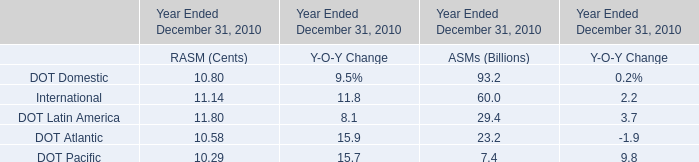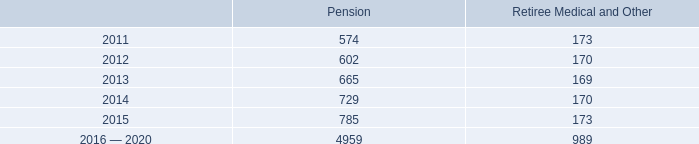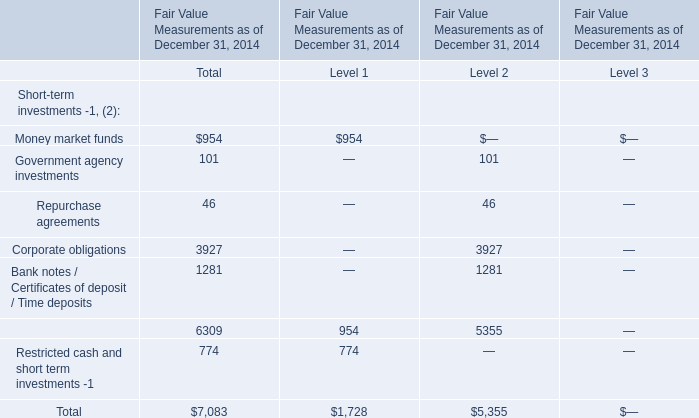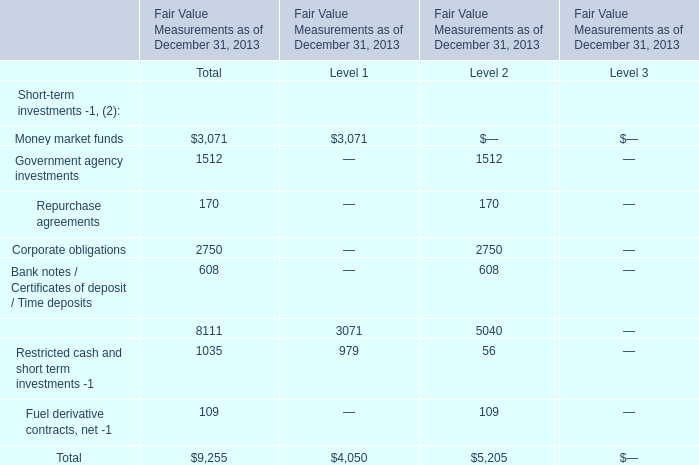How many kinds of Short-term investments staying in interval value 40 and value 150 in terms of Total in 2014? 
Answer: 2. 